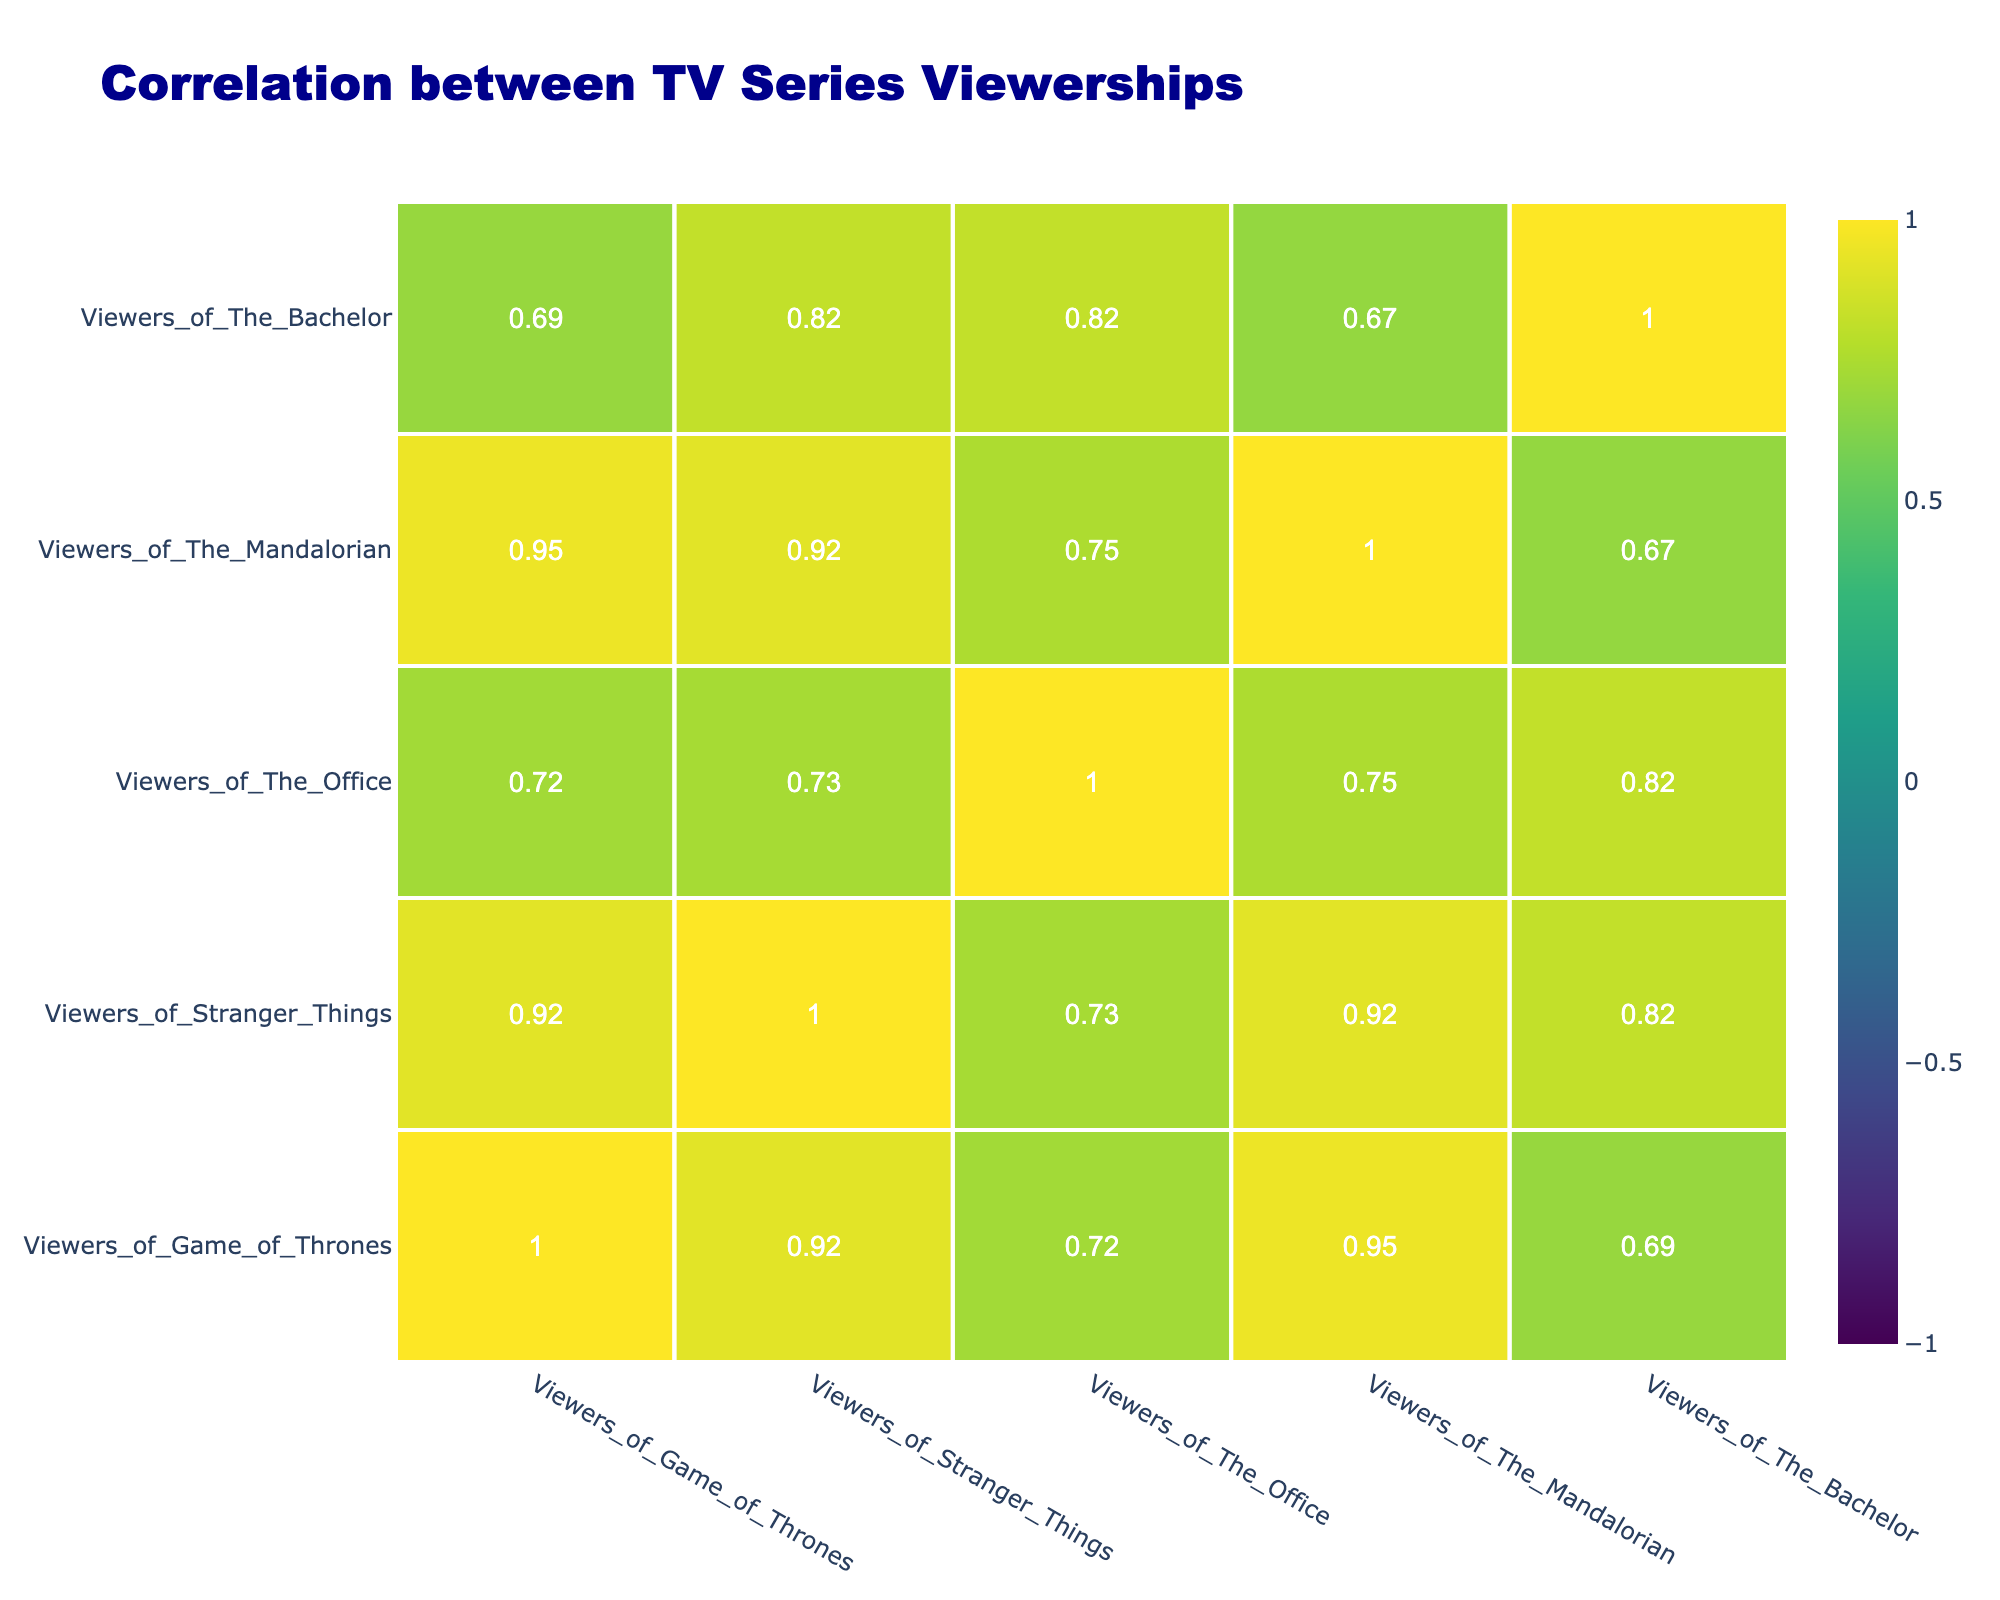What is the correlation between viewers of Game of Thrones and viewers of Stranger Things? By examining the correlation matrix from the table, we can find the value corresponding to the Game of Thrones and Stranger Things intersection. The value is 0.55, which indicates a moderate positive correlation.
Answer: 0.55 Which demographic has the highest viewership for The Mandalorian? Looking at the table, the highest viewership for The Mandalorian is among the 25-34 Female demographic with 80 viewers.
Answer: 80 Is it true that viewers of The Office are more likely to be Female than Male across all age groups? Analyzing the viewership data for The Office, we find that all Female demographics have higher viewership compared to their Male counterparts. For example, in the 18-24 age range, Female viewers are 65 while Male viewers are 60. Therefore, it is true.
Answer: Yes What is the difference in viewership between Male and Female for viewers of The Bachelor among the 18-24 age group? For the 18-24 demographic, Male viewers of The Bachelor amount to 40 while Female viewers account for 70. The difference in viewership is 70 - 40 = 30.
Answer: 30 What is the average viewership for Stranger Things across all demographics? To find this, we first sum the viewership numbers for Stranger Things: 70 (Male, 18-24) + 85 (Female, 18-24) + 75 (Male, 25-34) + 90 (Female, 25-34) + 60 (Male, 35-44) + 55 (Female, 35-44) + 40 (Male, 45-54) + 45 (Female, 45-54) + 20 (Male, 55-64) + 35 (Female, 55-64) = 530. Then we divide by the number of demographics (10), resulting in an average of 53.
Answer: 53 Which age group has the lowest number of viewers for The Office? Checking each age group's viewership for The Office, we find that the 55-64 age group has the lowest number of viewers for both Male (35) and Female (25), making it a combined total of 60 viewers, which is the least compared to others.
Answer: 60 